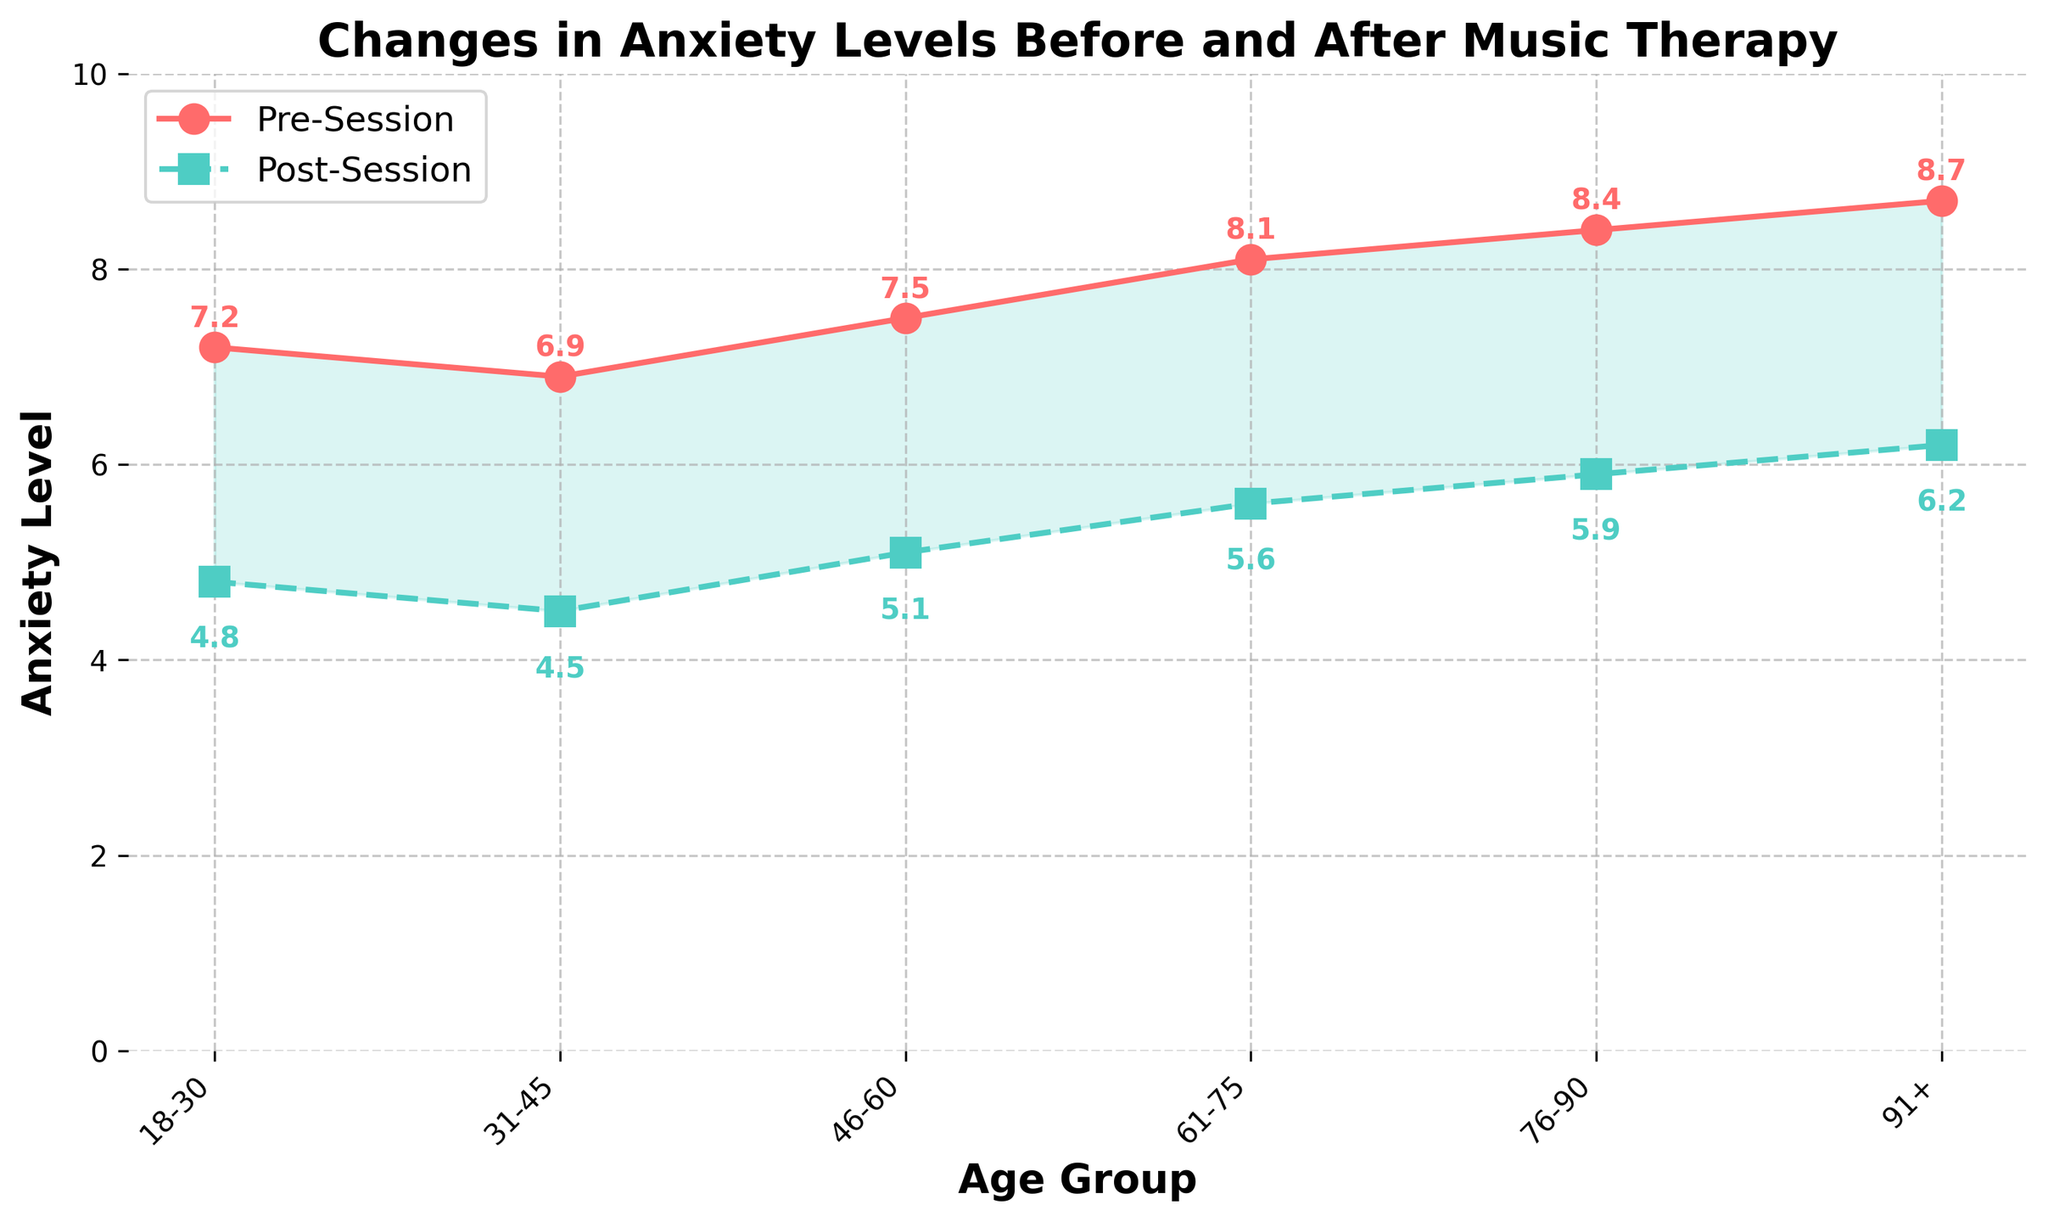What age group has the highest pre-session anxiety level? To identify which age group has the highest pre-session anxiety, look for the peak point on the line representing "Pre-Session Anxiety" in the figure. The highest value on this line is 8.7, corresponding to the "91+" age group.
Answer: 91+ Which age group shows the greatest reduction in anxiety levels after music therapy? To find the greatest reduction, calculate the difference between pre-session and post-session anxiety levels for each age group and identify the largest difference. The calculations are: 18-30: 2.4, 31-45: 2.4, 46-60: 2.4, 61-75: 2.5, 76-90: 2.5, 91+: 2.5. The greatest reduction is 2.5, occurring in the age groups 61-75, 76-90, and 91+.
Answer: 61-75, 76-90, and 91+ What is the average pre-session anxiety level across all age groups? To calculate the average pre-session anxiety level, sum all pre-session anxiety values and divide by the number of age groups. The sum is 7.2 + 6.9 + 7.5 + 8.1 + 8.4 + 8.7 = 46.8. Divide this by 6 (number of age groups) to get 7.8.
Answer: 7.8 Which two age groups post the smallest change in anxiety levels after music therapy? To determine the smallest changes, calculate the difference between pre-session and post-session values for each age group and find the smallest differences. The calculations are: 18-30: 2.4, 31-45: 2.4, 46-60: 2.4, 61-75: 2.5, 76-90: 2.5, 91+: 2.5. The smallest change is 2.4, occurring in the age groups 18-30, 31-45, and 46-60. Thus, the two age groups with the smallest change are among these.
Answer: 18-30, 31-45, and 46-60 What is the difference in post-session anxiety levels between the age groups 76-90 and 31-45? To find this difference, subtract the post-session anxiety for the 31-45 age group from the post-session anxiety for the 76-90 age group. This is 5.9 - 4.5 = 1.4.
Answer: 1.4 Do anxiety levels decrease more in the younger age groups (18-30 and 31-45) or the older age groups (76-90 and 91+)? To answer this, compare the average reduction in anxiety levels for younger age groups with that for older age groups. Calculations: Younger (18-30, 31-45): (2.4 + 2.4) / 2 = 2.4; Older (76-90, 91+): (2.5 + 2.5) / 2 = 2.5. The older age groups show a slightly larger decrease.
Answer: Older age groups Which segment in the figure shows the greatest visual gap between pre-session and post-session anxiety levels? The largest visual gap occurs where the area between the two lines is the most extensive. This is more easily seen in the older age groups (61-75, 76-90, 91+) where the filled area between the lines is wide. The greatest gap is around the 91+ age group.
Answer: 91+ 